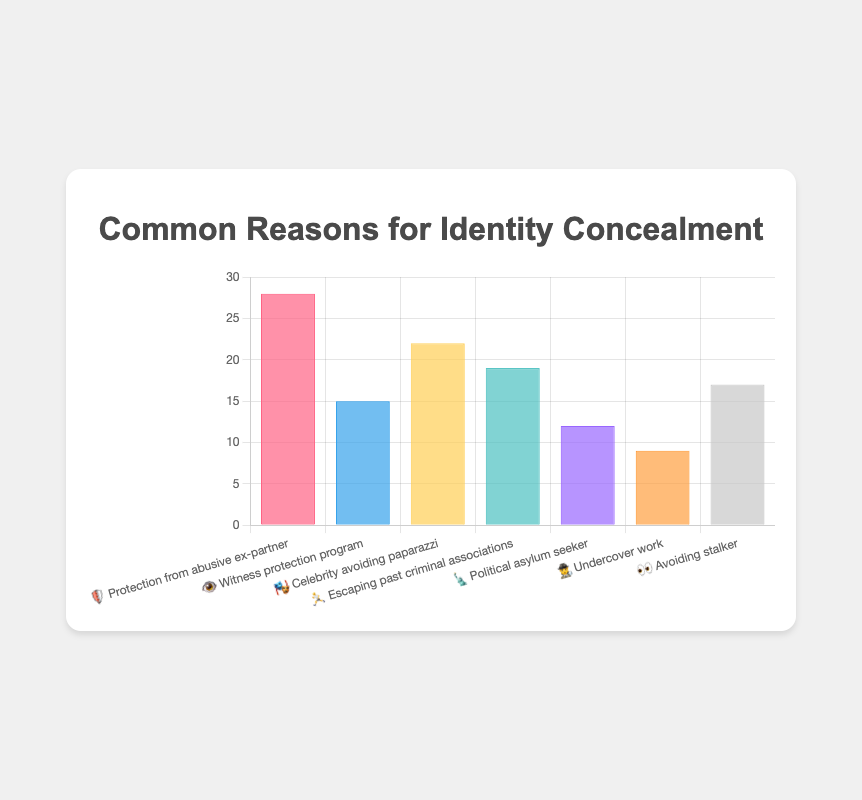What's the most common reason for identity concealment? The reason with the highest frequency is "Protection from abusive ex-partner," which has a frequency of 28.
Answer: Protection from abusive ex-partner Which reason for identity concealment has the lowest frequency? The reason with the lowest frequency is "Undercover work," which has a frequency of 9.
Answer: Undercover work What's the combined frequency of "Protection from abusive ex-partner" and "Celebrity avoiding paparazzi"? Add the frequencies of "Protection from abusive ex-partner" (28) and "Celebrity avoiding paparazzi" (22): 28 + 22 = 50.
Answer: 50 How many reasons have a frequency greater than 15? There are 4 reasons with frequencies greater than 15: "Protection from abusive ex-partner" (28), "Celebrity avoiding paparazzi" (22), "Escaping past criminal associations" (19), and "Avoiding stalker" (17).
Answer: 4 Which reason has a frequency that is closest to 20? The frequency of "Escaping past criminal associations" is 19, which is closest to 20 compared to the other reasons.
Answer: Escaping past criminal associations What's the frequency difference between the most and least common reasons? The most common reason's frequency is 28, and the least common is 9. The difference is 28 - 9 = 19.
Answer: 19 Is the frequency of "Political asylum seeker" higher or lower than the median frequency? The frequencies in ascending order are 9, 12, 15, 17, 19, 22, 28. The median is 17. "Political asylum seeker" has a frequency of 12, which is lower than the median.
Answer: Lower What is the total number of reasons listed in the figure? There are 7 reasons listed: "Protection from abusive ex-partner", "Witness protection program", "Celebrity avoiding paparazzi", "Escaping past criminal associations", "Political asylum seeker", "Undercover work", and "Avoiding stalker".
Answer: 7 